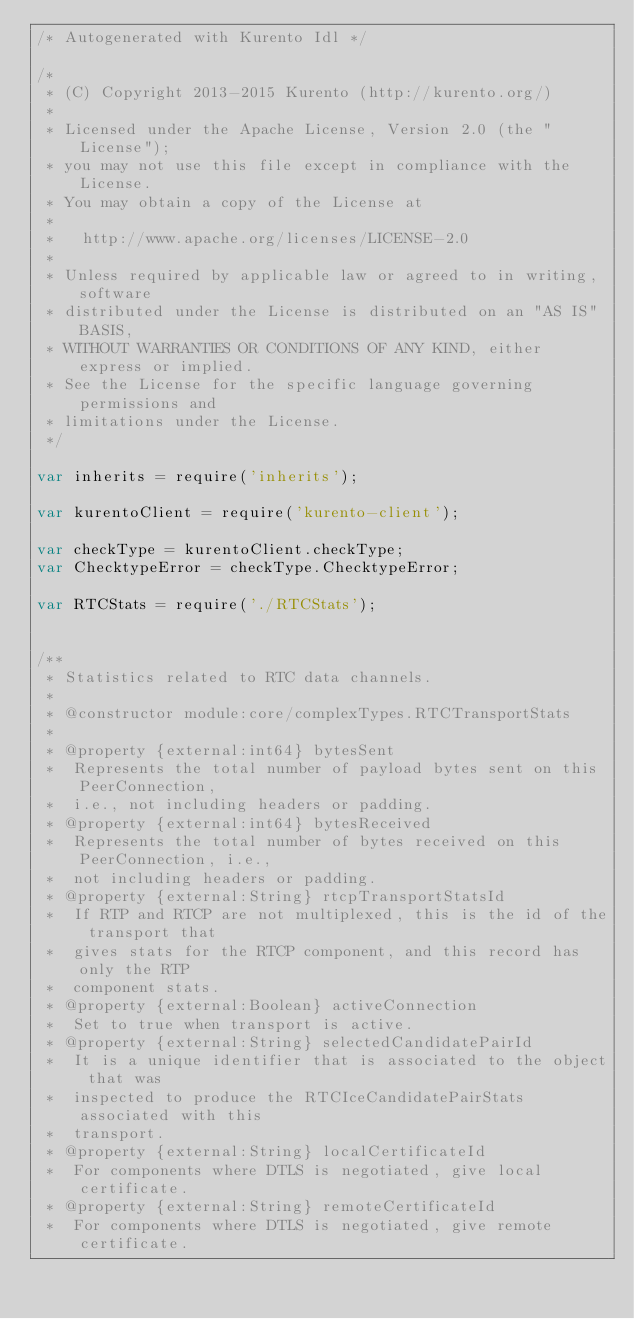<code> <loc_0><loc_0><loc_500><loc_500><_JavaScript_>/* Autogenerated with Kurento Idl */

/*
 * (C) Copyright 2013-2015 Kurento (http://kurento.org/)
 *
 * Licensed under the Apache License, Version 2.0 (the "License");
 * you may not use this file except in compliance with the License.
 * You may obtain a copy of the License at
 *
 *   http://www.apache.org/licenses/LICENSE-2.0
 *
 * Unless required by applicable law or agreed to in writing, software
 * distributed under the License is distributed on an "AS IS" BASIS,
 * WITHOUT WARRANTIES OR CONDITIONS OF ANY KIND, either express or implied.
 * See the License for the specific language governing permissions and
 * limitations under the License.
 */

var inherits = require('inherits');

var kurentoClient = require('kurento-client');

var checkType = kurentoClient.checkType;
var ChecktypeError = checkType.ChecktypeError;

var RTCStats = require('./RTCStats');


/**
 * Statistics related to RTC data channels.
 *
 * @constructor module:core/complexTypes.RTCTransportStats
 *
 * @property {external:int64} bytesSent
 *  Represents the total number of payload bytes sent on this PeerConnection, 
 *  i.e., not including headers or padding.
 * @property {external:int64} bytesReceived
 *  Represents the total number of bytes received on this PeerConnection, i.e., 
 *  not including headers or padding.
 * @property {external:String} rtcpTransportStatsId
 *  If RTP and RTCP are not multiplexed, this is the id of the transport that 
 *  gives stats for the RTCP component, and this record has only the RTP 
 *  component stats.
 * @property {external:Boolean} activeConnection
 *  Set to true when transport is active.
 * @property {external:String} selectedCandidatePairId
 *  It is a unique identifier that is associated to the object that was 
 *  inspected to produce the RTCIceCandidatePairStats associated with this 
 *  transport.
 * @property {external:String} localCertificateId
 *  For components where DTLS is negotiated, give local certificate.
 * @property {external:String} remoteCertificateId
 *  For components where DTLS is negotiated, give remote certificate.
</code> 